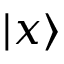<formula> <loc_0><loc_0><loc_500><loc_500>| x \rangle</formula> 